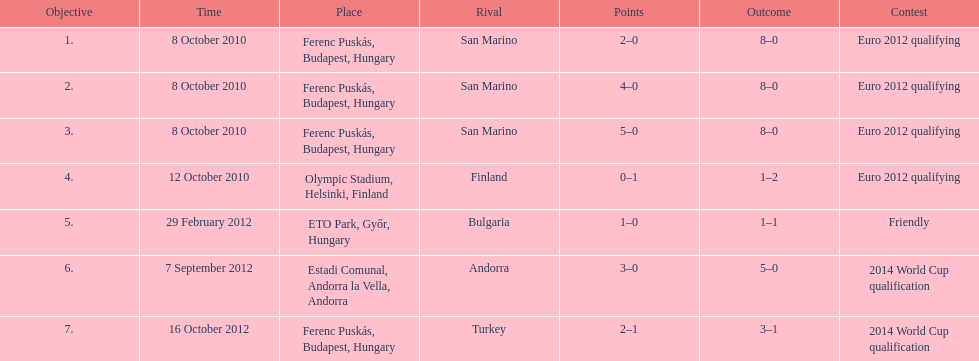How many goals were scored at the euro 2012 qualifying competition? 12. 